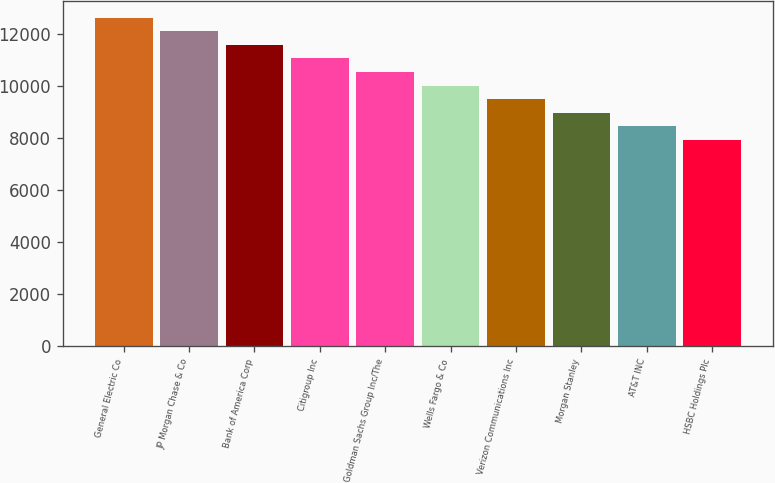Convert chart. <chart><loc_0><loc_0><loc_500><loc_500><bar_chart><fcel>General Electric Co<fcel>JP Morgan Chase & Co<fcel>Bank of America Corp<fcel>Citigroup Inc<fcel>Goldman Sachs Group Inc/The<fcel>Wells Fargo & Co<fcel>Verizon Communications Inc<fcel>Morgan Stanley<fcel>AT&T INC<fcel>HSBC Holdings Plc<nl><fcel>12639.8<fcel>12117.1<fcel>11594.4<fcel>11071.7<fcel>10549<fcel>10026.3<fcel>9503.6<fcel>8980.9<fcel>8458.2<fcel>7935.5<nl></chart> 